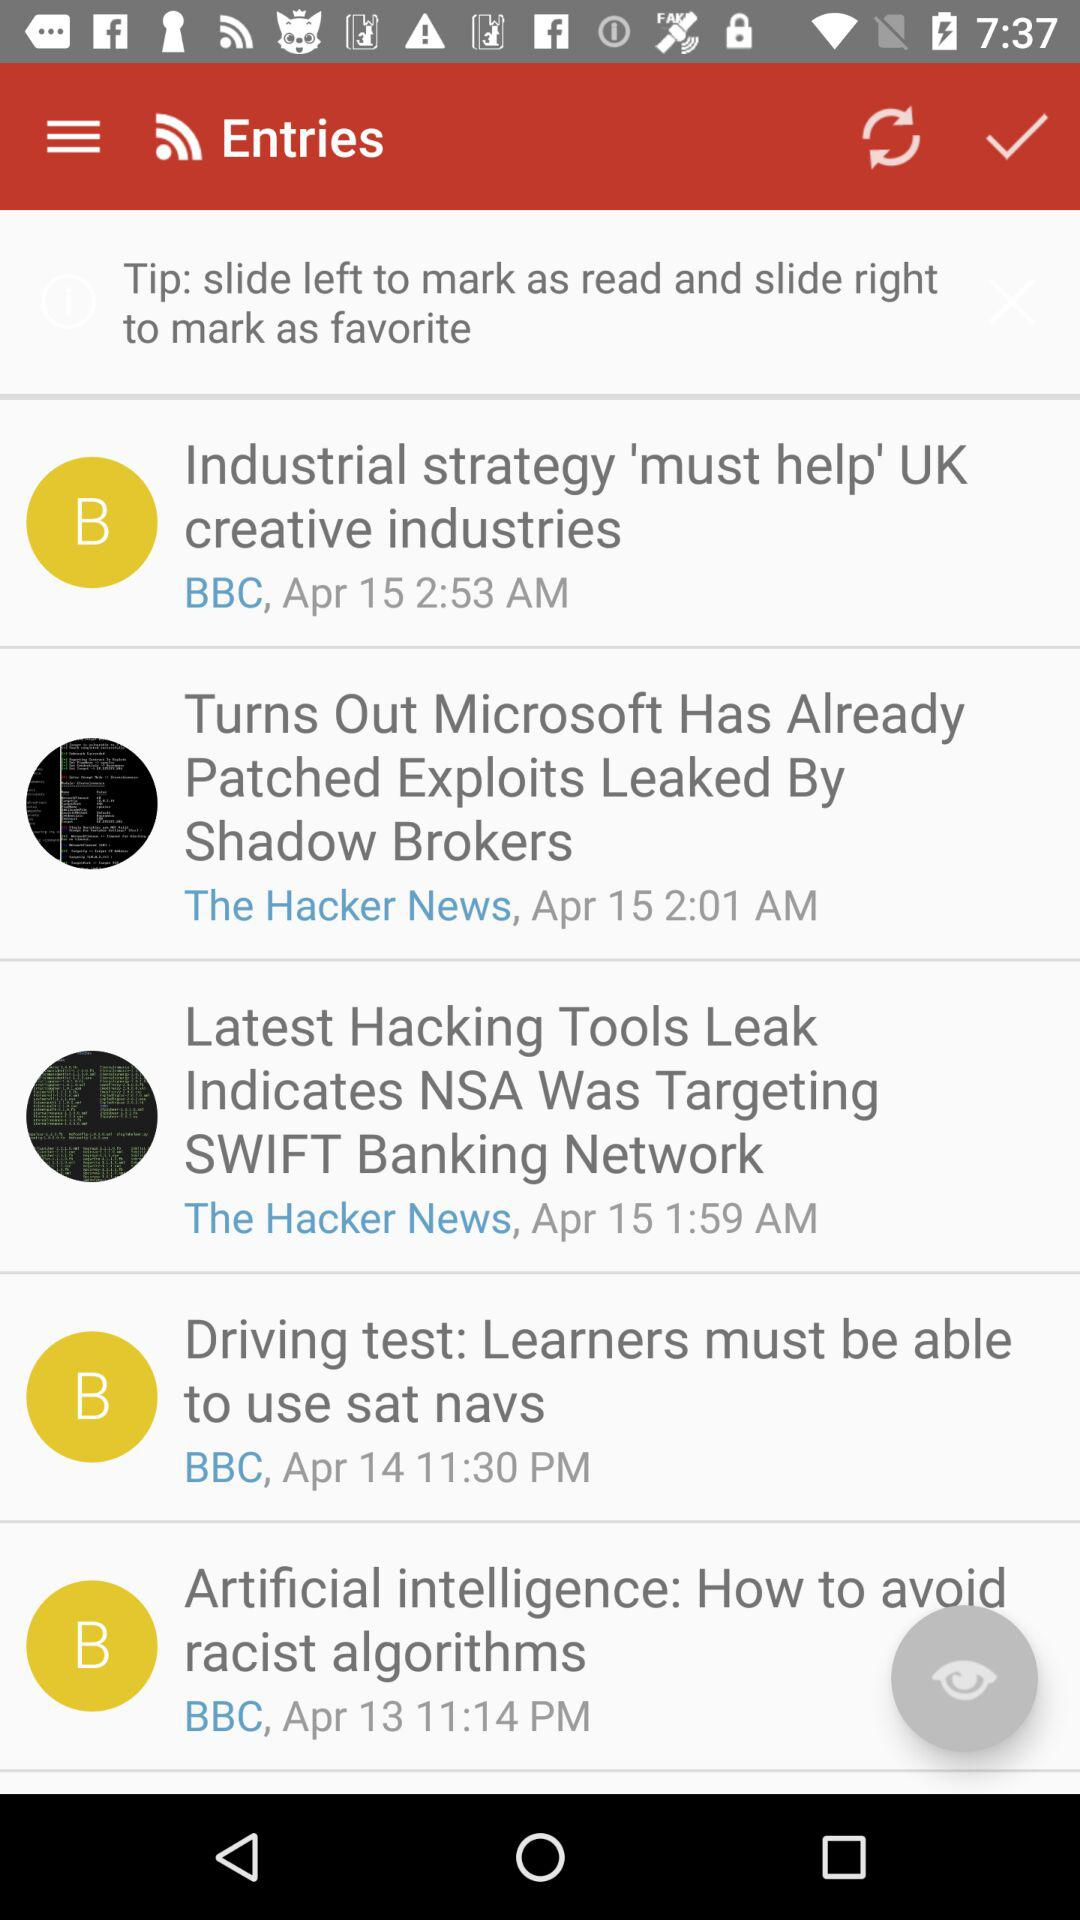Who is this application powered by?
When the provided information is insufficient, respond with <no answer>. <no answer> 